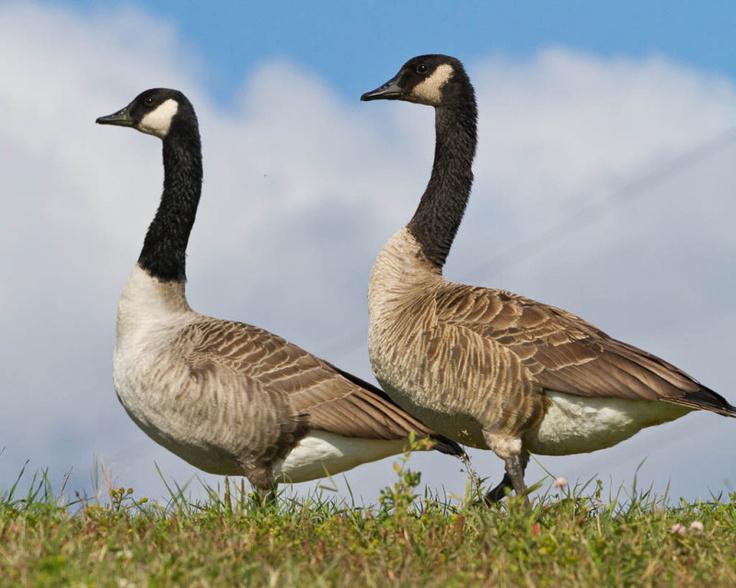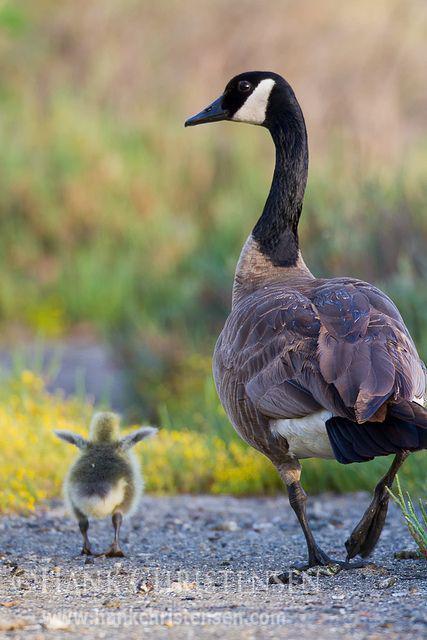The first image is the image on the left, the second image is the image on the right. Analyze the images presented: Is the assertion "An image shows at least one baby gosling next to an adult goose." valid? Answer yes or no. Yes. The first image is the image on the left, the second image is the image on the right. Evaluate the accuracy of this statement regarding the images: "One image shows an adult Canada goose and at least one gosling, while the other image shows all adult Canada geese.". Is it true? Answer yes or no. Yes. 